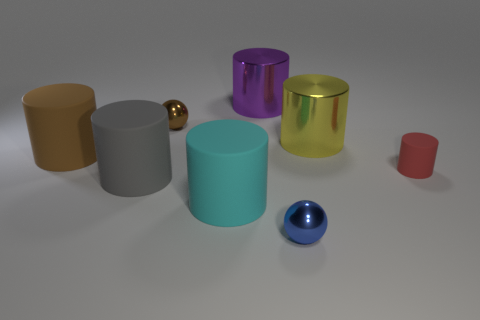Subtract 2 cylinders. How many cylinders are left? 4 Subtract all brown cylinders. How many cylinders are left? 5 Subtract all gray cylinders. How many cylinders are left? 5 Subtract all red cylinders. Subtract all green spheres. How many cylinders are left? 5 Add 2 blue metallic balls. How many objects exist? 10 Subtract all cylinders. How many objects are left? 2 Subtract 1 red cylinders. How many objects are left? 7 Subtract all big cylinders. Subtract all blue things. How many objects are left? 2 Add 1 tiny red rubber cylinders. How many tiny red rubber cylinders are left? 2 Add 8 blue rubber balls. How many blue rubber balls exist? 8 